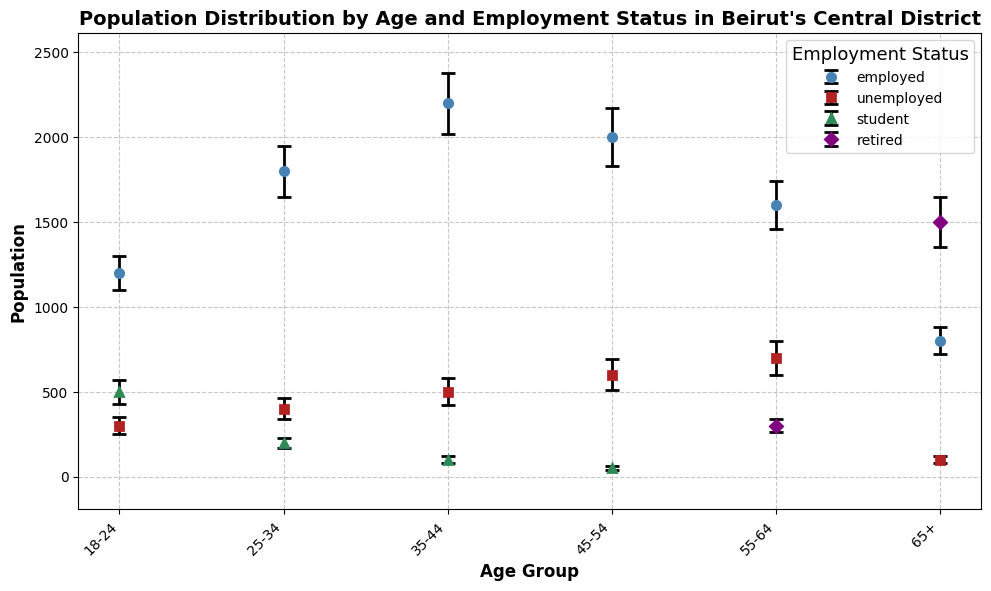What is the total population in the 35-44 age group? Sum the population values for all employment statuses within the 35-44 age group: 2200 (employed) + 500 (unemployed) + 100 (student) = 2800
Answer: 2800 Which age group has the highest number of employed individuals? Compare the population values for the 'employed' status across all age groups. The highest value is in the 35-44 age group (2200).
Answer: 35-44 What is the average population of unemployed individuals across all age groups? Calculate the sum of the unemployed population values across all age groups and divide by the number of age groups: (300 + 400 + 500 + 600 + 700 + 100) / 6 = 2600 / 6 ≈ 433.33
Answer: 433.33 In which age group do students have the lowest population? Compare the student population values across the age groups. The lowest value is in the 45-54 age group (50).
Answer: 45-54 Which employment status has the largest population error bar in the 55-64 age group? Compare the error values for each employment status in the 55-64 age group. The largest error is for the unemployed status (100).
Answer: Unemployed Is the population of retirees in the 65+ age group greater than the population of unemployed individuals in the same age group? Compare the population values: Retired (1500) versus Unemployed (100). 1500 is greater than 100.
Answer: Yes What is the combined population of students in the 18-24 and 25-34 age groups? Sum the student population values in these two age groups: 500 (18-24) + 200 (25-34) = 700
Answer: 700 How does the population of employed individuals change from the 18-24 age group to the 45-54 age group? Subtract the population of employed individuals in the 18-24 age group from the 45-54 age group: 2000 (45-54) - 1200 (18-24) = 800
Answer: Increases by 800 Which age group has the smallest overall population considering all employment statuses? Sum the population values for all employment statuses within each age group and find the smallest value. The 18-24 age group has: 1200 + 300 + 500 = 2000, the 25-34 age group has: 1800 + 400 + 200 = 2400, the 35-44 age group has: 2200 + 500 + 100 = 2800, the 45-54 age group has: 2000 + 600 + 50 = 2650, the 55-64 age group has: 1600 + 700 + 300 = 2600, the 65+ age group has: 800 + 100 + 1500 = 2400. The smallest total is 2000 (18-24).
Answer: 18-24 What is the difference between the population of employed individuals in the age groups 25-34 and 55-64? Subtract the population of employed individuals in the 55-64 age group from the 25-34 age group: 1800 (25-34) - 1600 (55-64) = 200
Answer: 200 